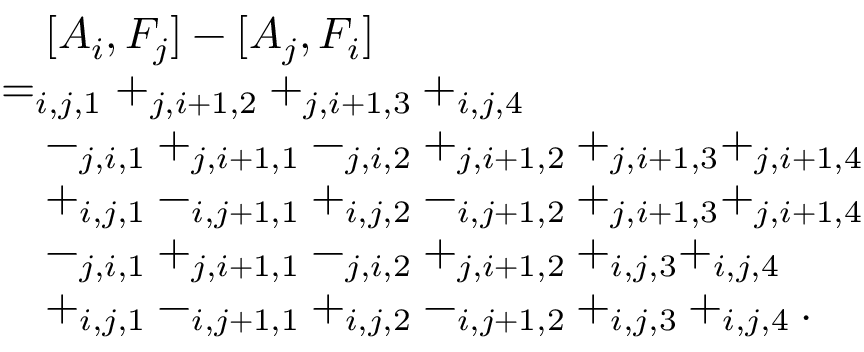<formula> <loc_0><loc_0><loc_500><loc_500>\begin{array} { r l } & { \quad [ A _ { i } , F _ { j } ] - [ A _ { j } , F _ { i } ] } \\ & { = _ { i , j , 1 } + _ { j , i + 1 , 2 } + _ { j , i + 1 , 3 } + _ { i , j , 4 } } \\ & { \quad - _ { j , i , 1 } + _ { j , i + 1 , 1 } - _ { j , i , 2 } + _ { j , i + 1 , 2 } + _ { j , i + 1 , 3 } + _ { j , i + 1 , 4 } } \\ & { \quad + _ { i , j , 1 } - _ { i , j + 1 , 1 } + _ { i , j , 2 } - _ { i , j + 1 , 2 } + _ { j , i + 1 , 3 } + _ { j , i + 1 , 4 } } \\ & { \quad - _ { j , i , 1 } + _ { j , i + 1 , 1 } - _ { j , i , 2 } + _ { j , i + 1 , 2 } + _ { i , j , 3 } + _ { i , j , 4 } } \\ & { \quad + _ { i , j , 1 } - _ { i , j + 1 , 1 } + _ { i , j , 2 } - _ { i , j + 1 , 2 } + _ { i , j , 3 } + _ { i , j , 4 } . } \end{array}</formula> 